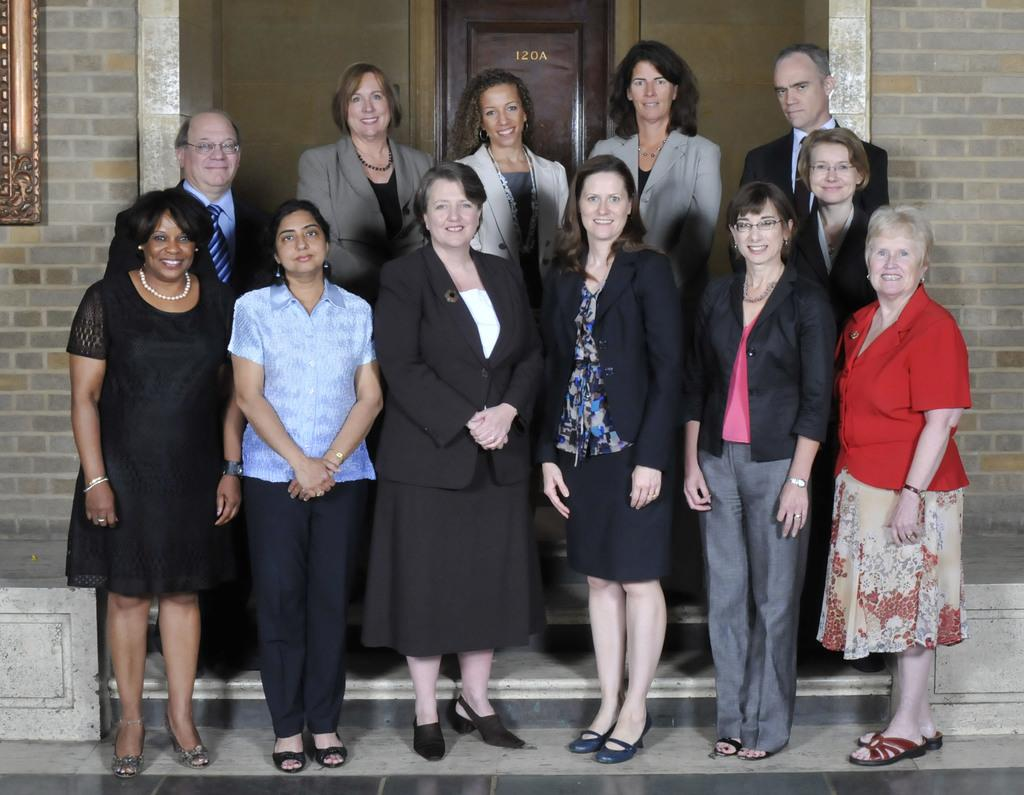How many people are in the image? There is a group of people in the image. What is the location of the people in the image? The people are standing in front of a door. What are the people in the image doing? The people are posing for a photo. What type of popcorn is being served on the dock in the image? There is no popcorn or dock present in the image. How many cushions are visible on the people in the image? There is no mention of cushions in the image; the people are posing for a photo. 